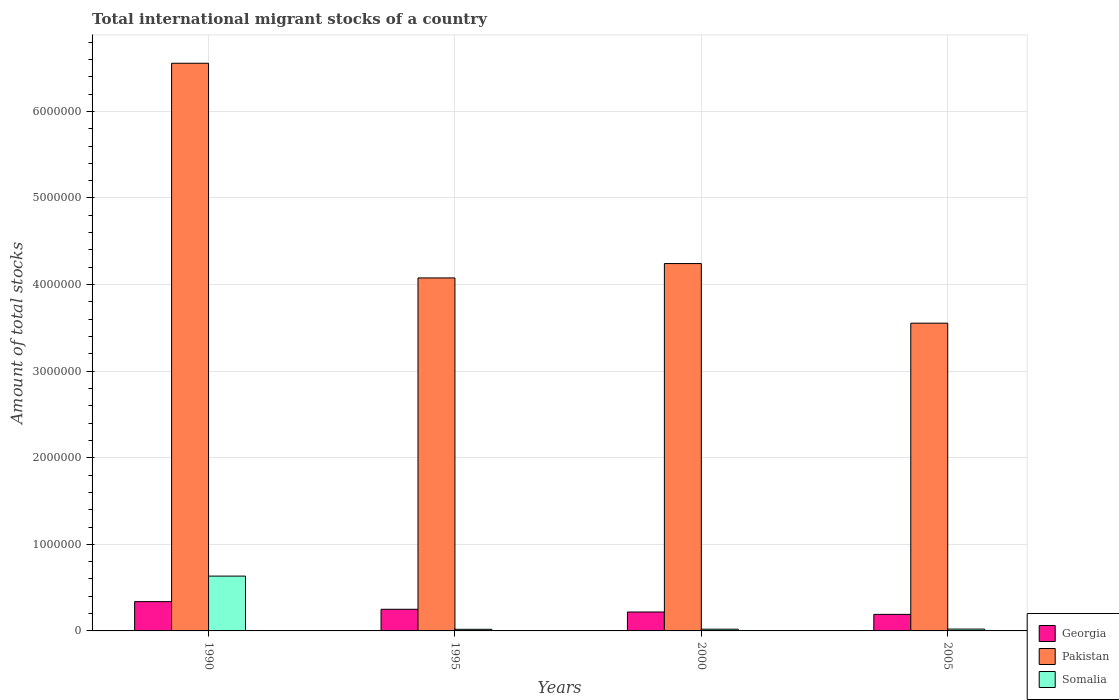How many groups of bars are there?
Make the answer very short. 4. Are the number of bars per tick equal to the number of legend labels?
Your answer should be compact. Yes. How many bars are there on the 1st tick from the left?
Give a very brief answer. 3. What is the label of the 2nd group of bars from the left?
Make the answer very short. 1995. What is the amount of total stocks in in Georgia in 2000?
Your response must be concise. 2.19e+05. Across all years, what is the maximum amount of total stocks in in Somalia?
Provide a short and direct response. 6.33e+05. Across all years, what is the minimum amount of total stocks in in Somalia?
Provide a short and direct response. 1.86e+04. In which year was the amount of total stocks in in Pakistan maximum?
Make the answer very short. 1990. What is the total amount of total stocks in in Pakistan in the graph?
Your answer should be compact. 1.84e+07. What is the difference between the amount of total stocks in in Pakistan in 1990 and that in 2000?
Offer a terse response. 2.31e+06. What is the difference between the amount of total stocks in in Somalia in 2000 and the amount of total stocks in in Pakistan in 1990?
Provide a short and direct response. -6.54e+06. What is the average amount of total stocks in in Somalia per year?
Offer a very short reply. 1.73e+05. In the year 2005, what is the difference between the amount of total stocks in in Somalia and amount of total stocks in in Georgia?
Your answer should be very brief. -1.70e+05. In how many years, is the amount of total stocks in in Pakistan greater than 5200000?
Give a very brief answer. 1. What is the ratio of the amount of total stocks in in Somalia in 1990 to that in 1995?
Offer a very short reply. 33.96. What is the difference between the highest and the second highest amount of total stocks in in Pakistan?
Offer a terse response. 2.31e+06. What is the difference between the highest and the lowest amount of total stocks in in Pakistan?
Make the answer very short. 3.00e+06. In how many years, is the amount of total stocks in in Somalia greater than the average amount of total stocks in in Somalia taken over all years?
Make the answer very short. 1. Is the sum of the amount of total stocks in in Pakistan in 1990 and 2000 greater than the maximum amount of total stocks in in Somalia across all years?
Offer a terse response. Yes. What does the 3rd bar from the left in 2005 represents?
Make the answer very short. Somalia. What does the 3rd bar from the right in 1990 represents?
Offer a very short reply. Georgia. How many years are there in the graph?
Offer a very short reply. 4. Are the values on the major ticks of Y-axis written in scientific E-notation?
Ensure brevity in your answer.  No. Does the graph contain any zero values?
Offer a terse response. No. Does the graph contain grids?
Ensure brevity in your answer.  Yes. How are the legend labels stacked?
Your response must be concise. Vertical. What is the title of the graph?
Provide a succinct answer. Total international migrant stocks of a country. Does "Turkmenistan" appear as one of the legend labels in the graph?
Keep it short and to the point. No. What is the label or title of the Y-axis?
Offer a very short reply. Amount of total stocks. What is the Amount of total stocks of Georgia in 1990?
Offer a terse response. 3.38e+05. What is the Amount of total stocks of Pakistan in 1990?
Ensure brevity in your answer.  6.56e+06. What is the Amount of total stocks of Somalia in 1990?
Keep it short and to the point. 6.33e+05. What is the Amount of total stocks in Georgia in 1995?
Your answer should be compact. 2.50e+05. What is the Amount of total stocks of Pakistan in 1995?
Ensure brevity in your answer.  4.08e+06. What is the Amount of total stocks in Somalia in 1995?
Offer a very short reply. 1.86e+04. What is the Amount of total stocks of Georgia in 2000?
Offer a terse response. 2.19e+05. What is the Amount of total stocks in Pakistan in 2000?
Provide a succinct answer. 4.24e+06. What is the Amount of total stocks in Somalia in 2000?
Keep it short and to the point. 1.99e+04. What is the Amount of total stocks of Georgia in 2005?
Make the answer very short. 1.91e+05. What is the Amount of total stocks of Pakistan in 2005?
Offer a very short reply. 3.55e+06. What is the Amount of total stocks of Somalia in 2005?
Ensure brevity in your answer.  2.13e+04. Across all years, what is the maximum Amount of total stocks in Georgia?
Offer a terse response. 3.38e+05. Across all years, what is the maximum Amount of total stocks of Pakistan?
Provide a short and direct response. 6.56e+06. Across all years, what is the maximum Amount of total stocks in Somalia?
Provide a short and direct response. 6.33e+05. Across all years, what is the minimum Amount of total stocks in Georgia?
Make the answer very short. 1.91e+05. Across all years, what is the minimum Amount of total stocks of Pakistan?
Your answer should be very brief. 3.55e+06. Across all years, what is the minimum Amount of total stocks in Somalia?
Give a very brief answer. 1.86e+04. What is the total Amount of total stocks in Georgia in the graph?
Your answer should be compact. 9.98e+05. What is the total Amount of total stocks in Pakistan in the graph?
Ensure brevity in your answer.  1.84e+07. What is the total Amount of total stocks of Somalia in the graph?
Your answer should be compact. 6.93e+05. What is the difference between the Amount of total stocks of Georgia in 1990 and that in 1995?
Offer a very short reply. 8.84e+04. What is the difference between the Amount of total stocks of Pakistan in 1990 and that in 1995?
Your answer should be compact. 2.48e+06. What is the difference between the Amount of total stocks of Somalia in 1990 and that in 1995?
Offer a terse response. 6.14e+05. What is the difference between the Amount of total stocks in Georgia in 1990 and that in 2000?
Offer a very short reply. 1.20e+05. What is the difference between the Amount of total stocks of Pakistan in 1990 and that in 2000?
Your answer should be very brief. 2.31e+06. What is the difference between the Amount of total stocks of Somalia in 1990 and that in 2000?
Offer a very short reply. 6.13e+05. What is the difference between the Amount of total stocks in Georgia in 1990 and that in 2005?
Keep it short and to the point. 1.47e+05. What is the difference between the Amount of total stocks in Pakistan in 1990 and that in 2005?
Your answer should be very brief. 3.00e+06. What is the difference between the Amount of total stocks of Somalia in 1990 and that in 2005?
Your response must be concise. 6.12e+05. What is the difference between the Amount of total stocks of Georgia in 1995 and that in 2000?
Your response must be concise. 3.13e+04. What is the difference between the Amount of total stocks in Pakistan in 1995 and that in 2000?
Keep it short and to the point. -1.66e+05. What is the difference between the Amount of total stocks in Somalia in 1995 and that in 2000?
Make the answer very short. -1229. What is the difference between the Amount of total stocks in Georgia in 1995 and that in 2005?
Give a very brief answer. 5.87e+04. What is the difference between the Amount of total stocks in Pakistan in 1995 and that in 2005?
Provide a succinct answer. 5.23e+05. What is the difference between the Amount of total stocks of Somalia in 1995 and that in 2005?
Offer a terse response. -2627. What is the difference between the Amount of total stocks of Georgia in 2000 and that in 2005?
Give a very brief answer. 2.74e+04. What is the difference between the Amount of total stocks of Pakistan in 2000 and that in 2005?
Your response must be concise. 6.89e+05. What is the difference between the Amount of total stocks in Somalia in 2000 and that in 2005?
Make the answer very short. -1398. What is the difference between the Amount of total stocks of Georgia in 1990 and the Amount of total stocks of Pakistan in 1995?
Keep it short and to the point. -3.74e+06. What is the difference between the Amount of total stocks of Georgia in 1990 and the Amount of total stocks of Somalia in 1995?
Make the answer very short. 3.20e+05. What is the difference between the Amount of total stocks in Pakistan in 1990 and the Amount of total stocks in Somalia in 1995?
Make the answer very short. 6.54e+06. What is the difference between the Amount of total stocks of Georgia in 1990 and the Amount of total stocks of Pakistan in 2000?
Provide a succinct answer. -3.90e+06. What is the difference between the Amount of total stocks of Georgia in 1990 and the Amount of total stocks of Somalia in 2000?
Make the answer very short. 3.18e+05. What is the difference between the Amount of total stocks of Pakistan in 1990 and the Amount of total stocks of Somalia in 2000?
Provide a short and direct response. 6.54e+06. What is the difference between the Amount of total stocks in Georgia in 1990 and the Amount of total stocks in Pakistan in 2005?
Offer a very short reply. -3.22e+06. What is the difference between the Amount of total stocks of Georgia in 1990 and the Amount of total stocks of Somalia in 2005?
Give a very brief answer. 3.17e+05. What is the difference between the Amount of total stocks of Pakistan in 1990 and the Amount of total stocks of Somalia in 2005?
Keep it short and to the point. 6.53e+06. What is the difference between the Amount of total stocks in Georgia in 1995 and the Amount of total stocks in Pakistan in 2000?
Provide a succinct answer. -3.99e+06. What is the difference between the Amount of total stocks in Georgia in 1995 and the Amount of total stocks in Somalia in 2000?
Ensure brevity in your answer.  2.30e+05. What is the difference between the Amount of total stocks of Pakistan in 1995 and the Amount of total stocks of Somalia in 2000?
Give a very brief answer. 4.06e+06. What is the difference between the Amount of total stocks of Georgia in 1995 and the Amount of total stocks of Pakistan in 2005?
Ensure brevity in your answer.  -3.30e+06. What is the difference between the Amount of total stocks in Georgia in 1995 and the Amount of total stocks in Somalia in 2005?
Make the answer very short. 2.29e+05. What is the difference between the Amount of total stocks in Pakistan in 1995 and the Amount of total stocks in Somalia in 2005?
Your answer should be very brief. 4.06e+06. What is the difference between the Amount of total stocks in Georgia in 2000 and the Amount of total stocks in Pakistan in 2005?
Your answer should be very brief. -3.34e+06. What is the difference between the Amount of total stocks in Georgia in 2000 and the Amount of total stocks in Somalia in 2005?
Your answer should be compact. 1.97e+05. What is the difference between the Amount of total stocks in Pakistan in 2000 and the Amount of total stocks in Somalia in 2005?
Provide a short and direct response. 4.22e+06. What is the average Amount of total stocks of Georgia per year?
Provide a succinct answer. 2.50e+05. What is the average Amount of total stocks in Pakistan per year?
Make the answer very short. 4.61e+06. What is the average Amount of total stocks of Somalia per year?
Your answer should be very brief. 1.73e+05. In the year 1990, what is the difference between the Amount of total stocks of Georgia and Amount of total stocks of Pakistan?
Offer a very short reply. -6.22e+06. In the year 1990, what is the difference between the Amount of total stocks in Georgia and Amount of total stocks in Somalia?
Keep it short and to the point. -2.95e+05. In the year 1990, what is the difference between the Amount of total stocks in Pakistan and Amount of total stocks in Somalia?
Offer a terse response. 5.92e+06. In the year 1995, what is the difference between the Amount of total stocks of Georgia and Amount of total stocks of Pakistan?
Make the answer very short. -3.83e+06. In the year 1995, what is the difference between the Amount of total stocks of Georgia and Amount of total stocks of Somalia?
Provide a short and direct response. 2.31e+05. In the year 1995, what is the difference between the Amount of total stocks in Pakistan and Amount of total stocks in Somalia?
Offer a terse response. 4.06e+06. In the year 2000, what is the difference between the Amount of total stocks of Georgia and Amount of total stocks of Pakistan?
Provide a succinct answer. -4.02e+06. In the year 2000, what is the difference between the Amount of total stocks of Georgia and Amount of total stocks of Somalia?
Offer a terse response. 1.99e+05. In the year 2000, what is the difference between the Amount of total stocks in Pakistan and Amount of total stocks in Somalia?
Your answer should be very brief. 4.22e+06. In the year 2005, what is the difference between the Amount of total stocks of Georgia and Amount of total stocks of Pakistan?
Make the answer very short. -3.36e+06. In the year 2005, what is the difference between the Amount of total stocks in Georgia and Amount of total stocks in Somalia?
Offer a very short reply. 1.70e+05. In the year 2005, what is the difference between the Amount of total stocks of Pakistan and Amount of total stocks of Somalia?
Your response must be concise. 3.53e+06. What is the ratio of the Amount of total stocks in Georgia in 1990 to that in 1995?
Provide a short and direct response. 1.35. What is the ratio of the Amount of total stocks of Pakistan in 1990 to that in 1995?
Make the answer very short. 1.61. What is the ratio of the Amount of total stocks in Somalia in 1990 to that in 1995?
Provide a succinct answer. 33.96. What is the ratio of the Amount of total stocks of Georgia in 1990 to that in 2000?
Keep it short and to the point. 1.55. What is the ratio of the Amount of total stocks of Pakistan in 1990 to that in 2000?
Provide a short and direct response. 1.55. What is the ratio of the Amount of total stocks in Somalia in 1990 to that in 2000?
Offer a terse response. 31.86. What is the ratio of the Amount of total stocks in Georgia in 1990 to that in 2005?
Your answer should be compact. 1.77. What is the ratio of the Amount of total stocks in Pakistan in 1990 to that in 2005?
Provide a short and direct response. 1.84. What is the ratio of the Amount of total stocks of Somalia in 1990 to that in 2005?
Your response must be concise. 29.76. What is the ratio of the Amount of total stocks in Georgia in 1995 to that in 2000?
Provide a succinct answer. 1.14. What is the ratio of the Amount of total stocks of Pakistan in 1995 to that in 2000?
Offer a very short reply. 0.96. What is the ratio of the Amount of total stocks in Somalia in 1995 to that in 2000?
Provide a short and direct response. 0.94. What is the ratio of the Amount of total stocks of Georgia in 1995 to that in 2005?
Your answer should be very brief. 1.31. What is the ratio of the Amount of total stocks of Pakistan in 1995 to that in 2005?
Provide a short and direct response. 1.15. What is the ratio of the Amount of total stocks in Somalia in 1995 to that in 2005?
Provide a succinct answer. 0.88. What is the ratio of the Amount of total stocks in Georgia in 2000 to that in 2005?
Your answer should be very brief. 1.14. What is the ratio of the Amount of total stocks of Pakistan in 2000 to that in 2005?
Offer a terse response. 1.19. What is the ratio of the Amount of total stocks in Somalia in 2000 to that in 2005?
Your answer should be very brief. 0.93. What is the difference between the highest and the second highest Amount of total stocks in Georgia?
Your answer should be compact. 8.84e+04. What is the difference between the highest and the second highest Amount of total stocks of Pakistan?
Keep it short and to the point. 2.31e+06. What is the difference between the highest and the second highest Amount of total stocks of Somalia?
Your response must be concise. 6.12e+05. What is the difference between the highest and the lowest Amount of total stocks in Georgia?
Provide a short and direct response. 1.47e+05. What is the difference between the highest and the lowest Amount of total stocks of Pakistan?
Make the answer very short. 3.00e+06. What is the difference between the highest and the lowest Amount of total stocks of Somalia?
Offer a very short reply. 6.14e+05. 